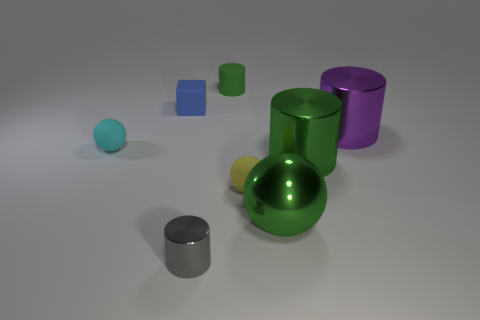Is the size of the matte ball that is to the left of the green rubber object the same as the purple metallic thing?
Ensure brevity in your answer.  No. Is there another cylinder that has the same color as the small shiny cylinder?
Make the answer very short. No. What is the size of the purple object that is made of the same material as the green sphere?
Offer a very short reply. Large. Are there more large metal objects to the right of the tiny cyan sphere than small gray shiny cylinders that are to the left of the small yellow thing?
Provide a short and direct response. Yes. How many other objects are the same material as the green sphere?
Your answer should be compact. 3. Is the material of the small cylinder to the right of the tiny gray shiny cylinder the same as the gray cylinder?
Your response must be concise. No. What shape is the tiny cyan thing?
Offer a very short reply. Sphere. Is the number of metallic spheres that are in front of the large purple shiny object greater than the number of purple shiny balls?
Give a very brief answer. Yes. Is there any other thing that is the same shape as the blue matte thing?
Keep it short and to the point. No. There is another tiny thing that is the same shape as the gray object; what color is it?
Provide a short and direct response. Green. 